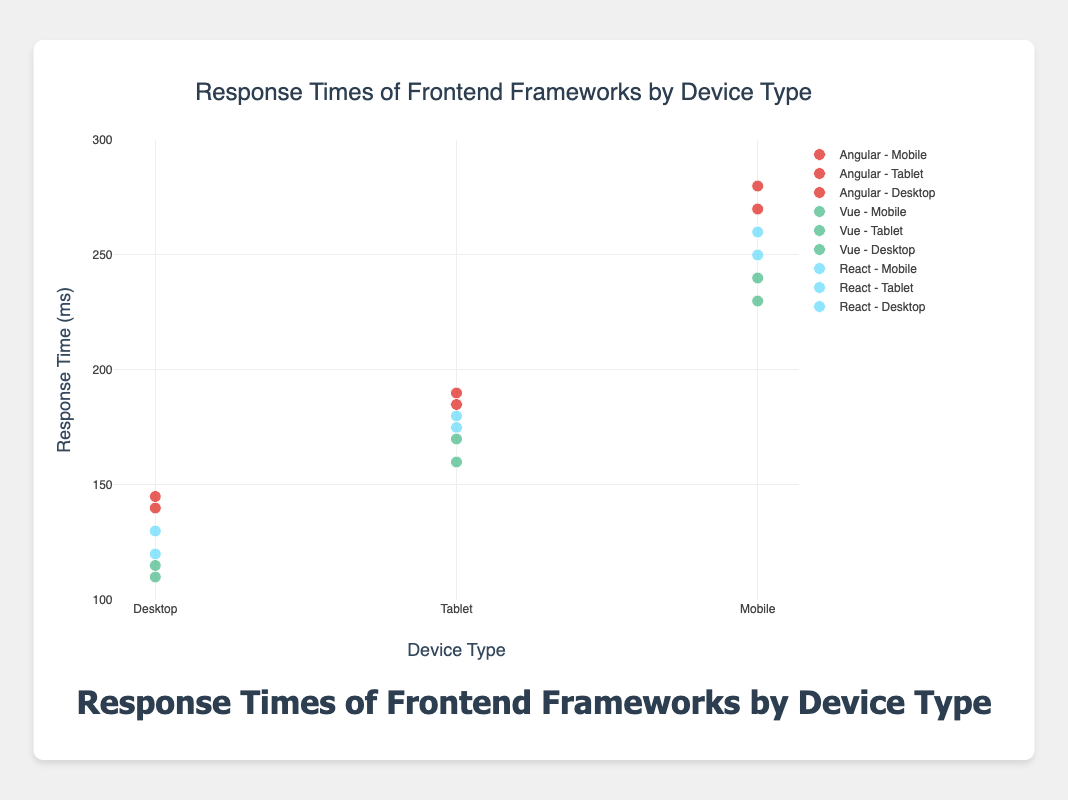What is the title of the chart? The title is positioned at the top center of the chart indicating its main subject. It reads "Response Times of Frontend Frameworks by Device Type".
Answer: Response Times of Frontend Frameworks by Device Type Which devices are compared in the scatter plot? The x-axis labels show the different device types for each frontend framework. These devices are Desktop, Tablet, and Mobile.
Answer: Desktop, Tablet, Mobile What color represents the React framework? The legend and markers indicate that the React framework is represented by a sky-blue color.
Answer: Sky-blue Among the React framework data points, what is the highest response time for Mobile devices? By examining the position of data points for "React - Mobile" on the y-axis, the highest response time recorded is 260 ms.
Answer: 260 ms Which frontend framework has the lowest response time on a Desktop? The y-axis values for each Desktop data point show that the Vue framework has the lowest response time, with a minimum of 110 ms.
Answer: Vue What is the average response time of the Vue framework on Tablets? The Vue framework has response times of 170 ms and 160 ms on Tablets. The average is calculated as (170 + 160) / 2 = 165 ms.
Answer: 165 ms Between React and Angular frameworks, which one has a higher average response time on Tablets? React's average response time on Tablets is (180 + 175) / 2 = 177.5 ms, and Angular's average response time on Tablets is (190 + 185) / 2 = 187.5 ms. Angular has a higher average.
Answer: Angular What is the range of response times for Mobile devices for all frameworks? The response times for Mobiles are 250-260 ms (React), 230-240 ms (Vue), and 270-280 ms (Angular). The overall range spans from 230 ms to 280 ms.
Answer: 230 ms to 280 ms Which framework generally performs faster across all device types? When comparing the range of response times for each framework, Vue shows the lowest overall times across Desktop (110-115 ms), Tablet (160-170 ms), and Mobile (230-240 ms).
Answer: Vue How can it be visually identified that the framework performance varies significantly by device type? The scatter plot shows distinct clusters of points for each device type within each framework, with noticeable differences in y-axis (response times), indicating variation. Angular's Mobile times are notably higher, while Vue's Desktop times are notably lower.
Answer: Differences in the height of clusters on the y-axis 